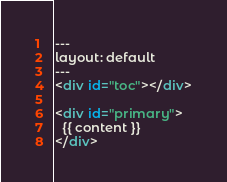<code> <loc_0><loc_0><loc_500><loc_500><_HTML_>---
layout: default
---
<div id="toc"></div>

<div id="primary">
  {{ content }}
</div>
</code> 